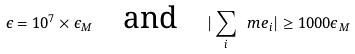<formula> <loc_0><loc_0><loc_500><loc_500>\epsilon = 1 0 ^ { 7 } \times \epsilon _ { M } \quad \text {and} \quad | \sum _ { i } \ m e _ { i } | \geq 1 0 0 0 \epsilon _ { M }</formula> 